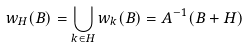Convert formula to latex. <formula><loc_0><loc_0><loc_500><loc_500>w _ { H } ( B ) = \bigcup _ { k \in H } w _ { k } ( B ) = A ^ { - 1 } ( B + H )</formula> 